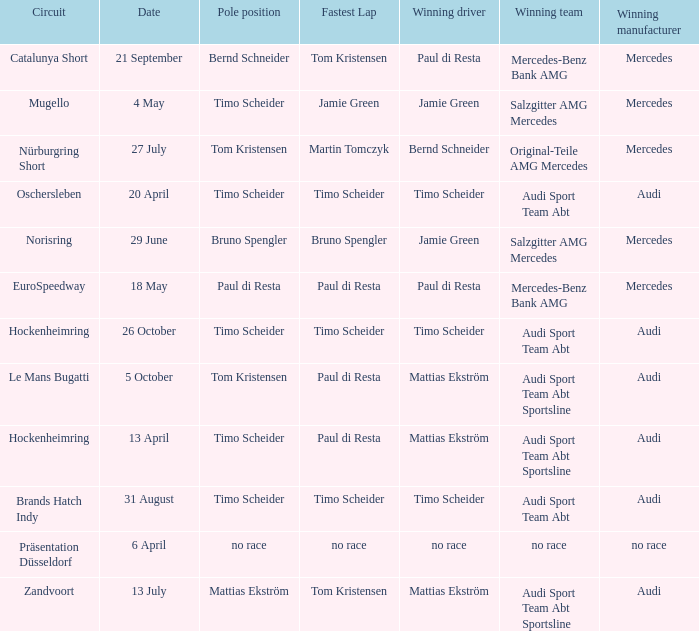Who is the winning driver of the Oschersleben circuit with Timo Scheider as the pole position? Timo Scheider. 